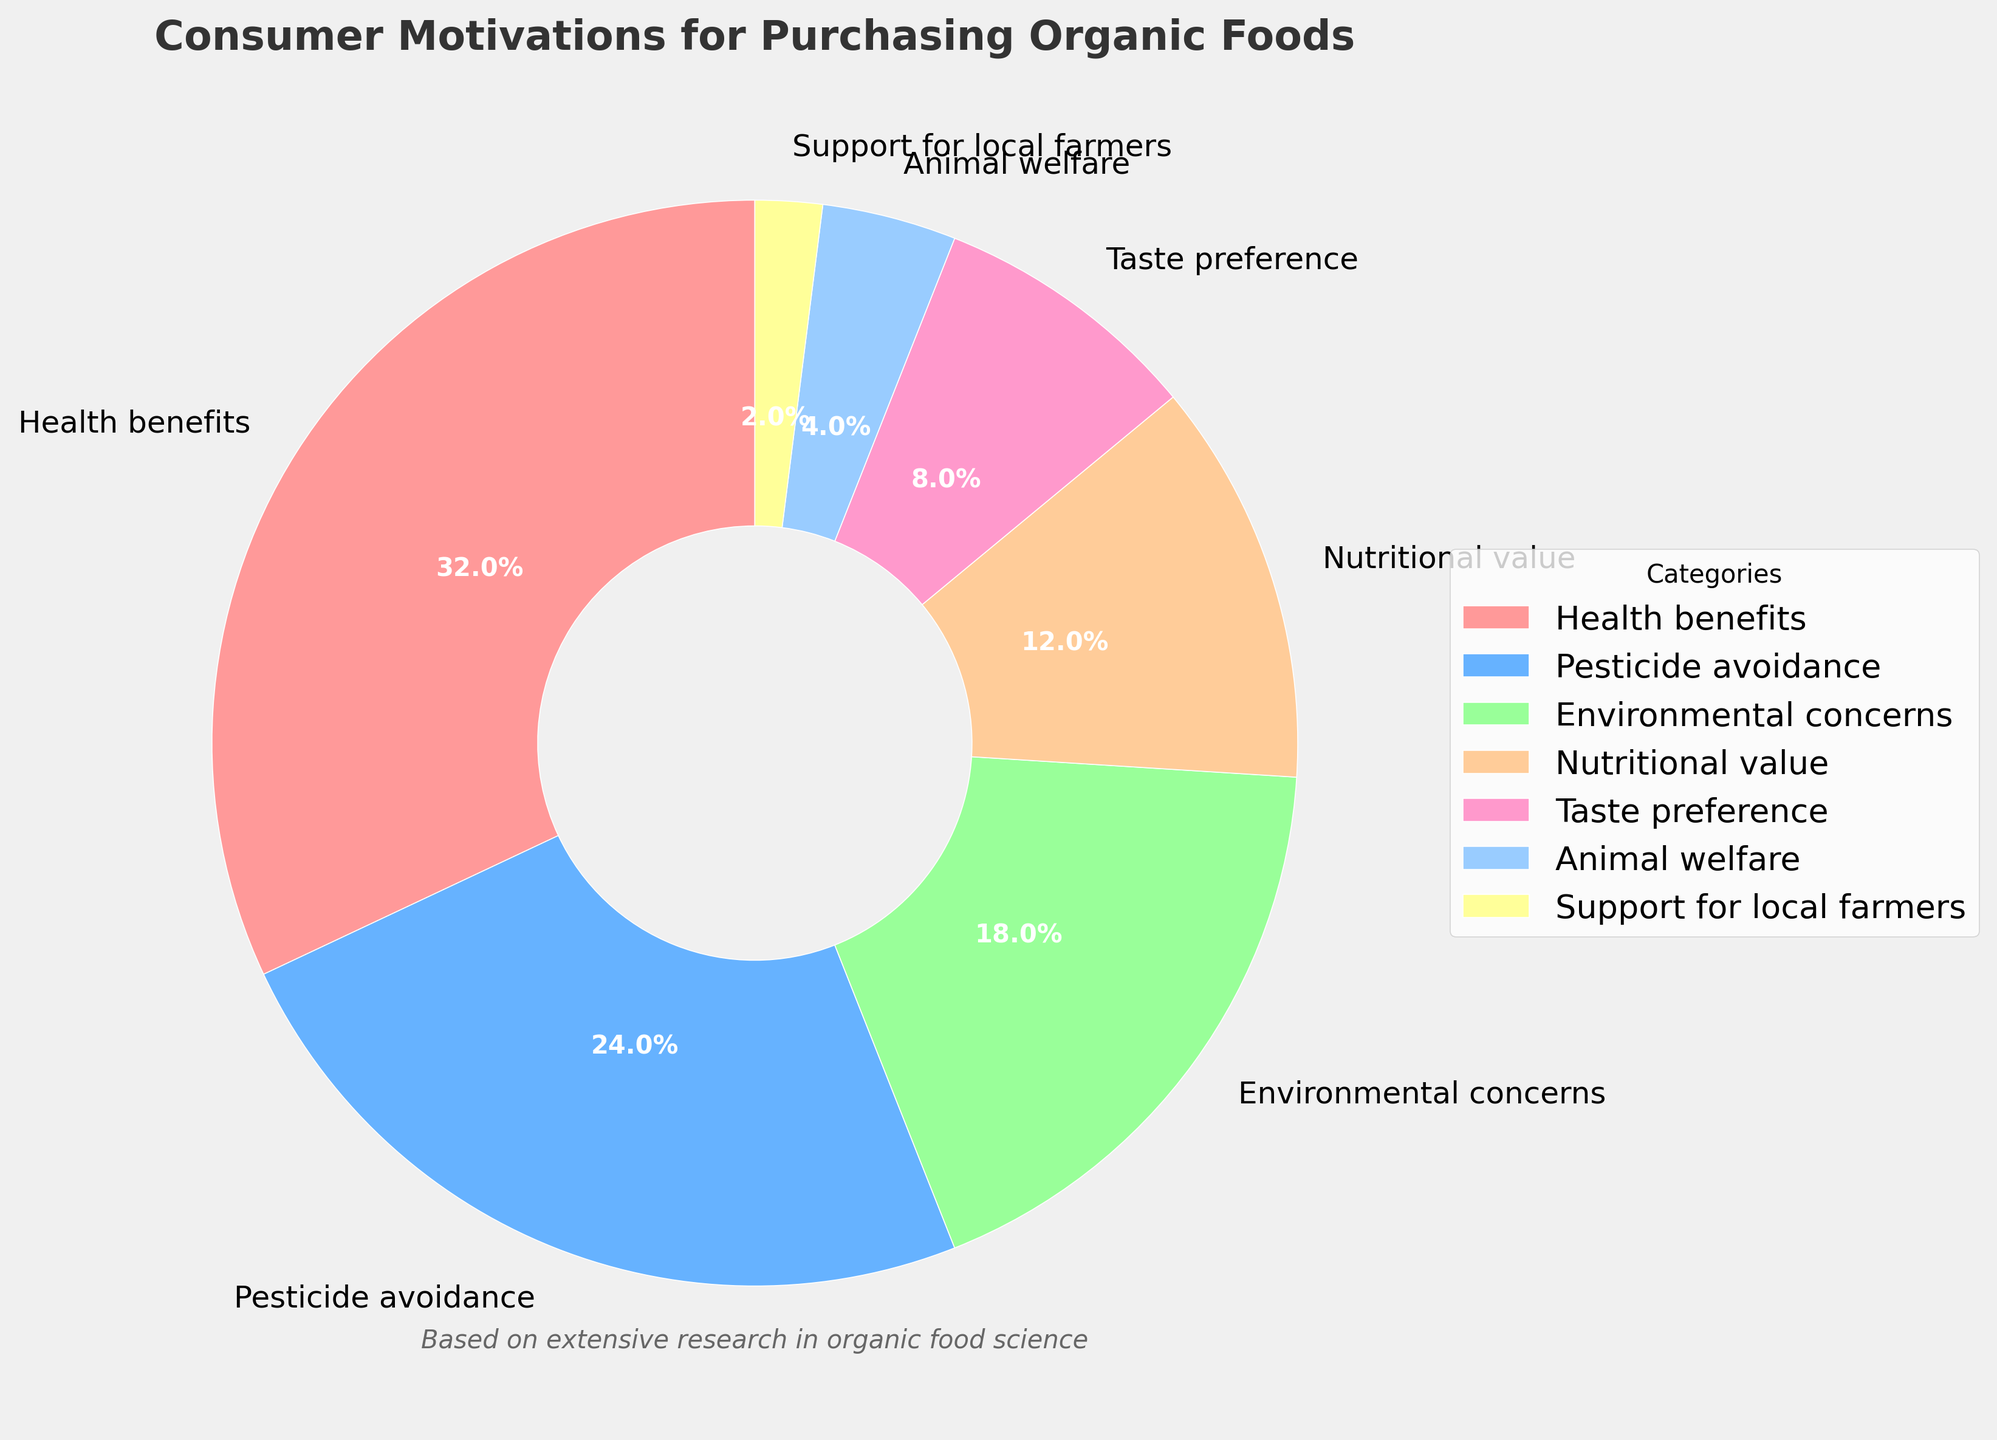What is the largest category in terms of consumer motivation for purchasing organic foods? The pie chart shows several categories with different percentages. The largest segment in terms of consumer motivation is the "Health benefits" category, which accounts for 32% of the total.
Answer: Health benefits Which category has the smallest percentage? By examining the pie chart, the category with the smallest segment (or the smallest percentage) is "Support for local farmers," which constitutes 2% of the total.
Answer: Support for local farmers How much more significant is the "Health benefits" motivation compared to the "Animal welfare" motivation? The "Health benefits" category is 32%, and the "Animal welfare" category is 4%. To find the difference, subtract the latter from the former: 32% - 4% = 28%.
Answer: 28% What are the combined percentages of the top three motivations for purchasing organic foods? The top three motivations are "Health benefits" (32%), "Pesticide avoidance" (24%), and "Environmental concerns" (18%). Adding these up: 32% + 24% + 18% = 74%.
Answer: 74% Which segment is more significant, "Environmental concerns" or the combined percentage of "Nutritional value" and "Taste preference"? "Environmental concerns" is 18%. "Nutritional value" is 12% and "Taste preference" is 8%. The sum of "Nutritional value" and "Taste preference" is 12% + 8% = 20%, which is greater than 18%.
Answer: Nutritional value and Taste preference Considering "Pesticide avoidance" and "Animal welfare," which category takes up more space in the pie chart and by how much? "Pesticide avoidance" is 24%, and "Animal welfare" is 4%. The difference is 24% - 4% = 20%. So, "Pesticide avoidance" takes up 20% more space than "Animal welfare."
Answer: Pesticide avoidance by 20% What percentage of consumer motivation is not related to "Health benefits"? "Health benefits" is 32%. Therefore, the rest of the motivations collectively constitute 100% - 32% = 68%.
Answer: 68% Between "Taste preference" and "Support for local farmers," which motivation has the smaller percentage and by what difference? "Taste preference" is 8%, and "Support for local farmers" is 2%. The difference is 8% - 2% = 6%. "Support for local farmers" has the smaller percentage by 6%.
Answer: Support for local farmers by 6% What is the difference in percentage points between the second largest and the second smallest categories? The second largest category is "Pesticide avoidance" at 24%, and the second smallest category is "Animal welfare" at 4%. The difference is 24% - 4% = 20%.
Answer: 20% 